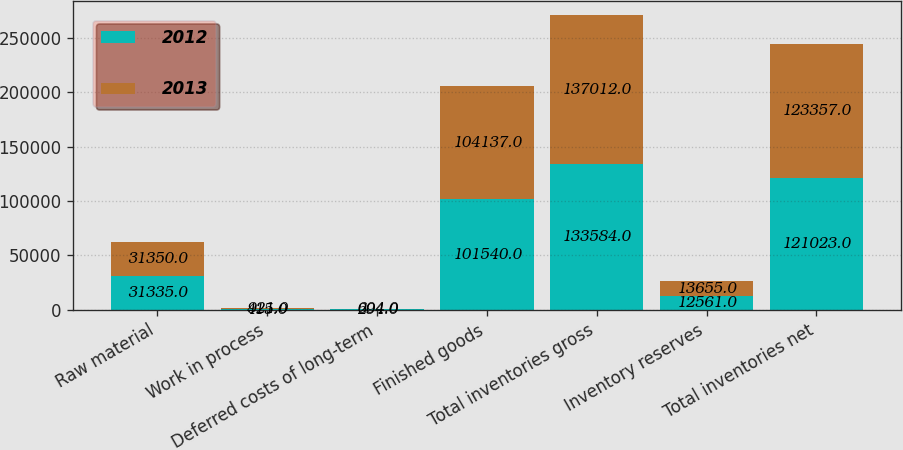Convert chart. <chart><loc_0><loc_0><loc_500><loc_500><stacked_bar_chart><ecel><fcel>Raw material<fcel>Work in process<fcel>Deferred costs of long-term<fcel>Finished goods<fcel>Total inventories gross<fcel>Inventory reserves<fcel>Total inventories net<nl><fcel>2012<fcel>31335<fcel>415<fcel>294<fcel>101540<fcel>133584<fcel>12561<fcel>121023<nl><fcel>2013<fcel>31350<fcel>921<fcel>604<fcel>104137<fcel>137012<fcel>13655<fcel>123357<nl></chart> 